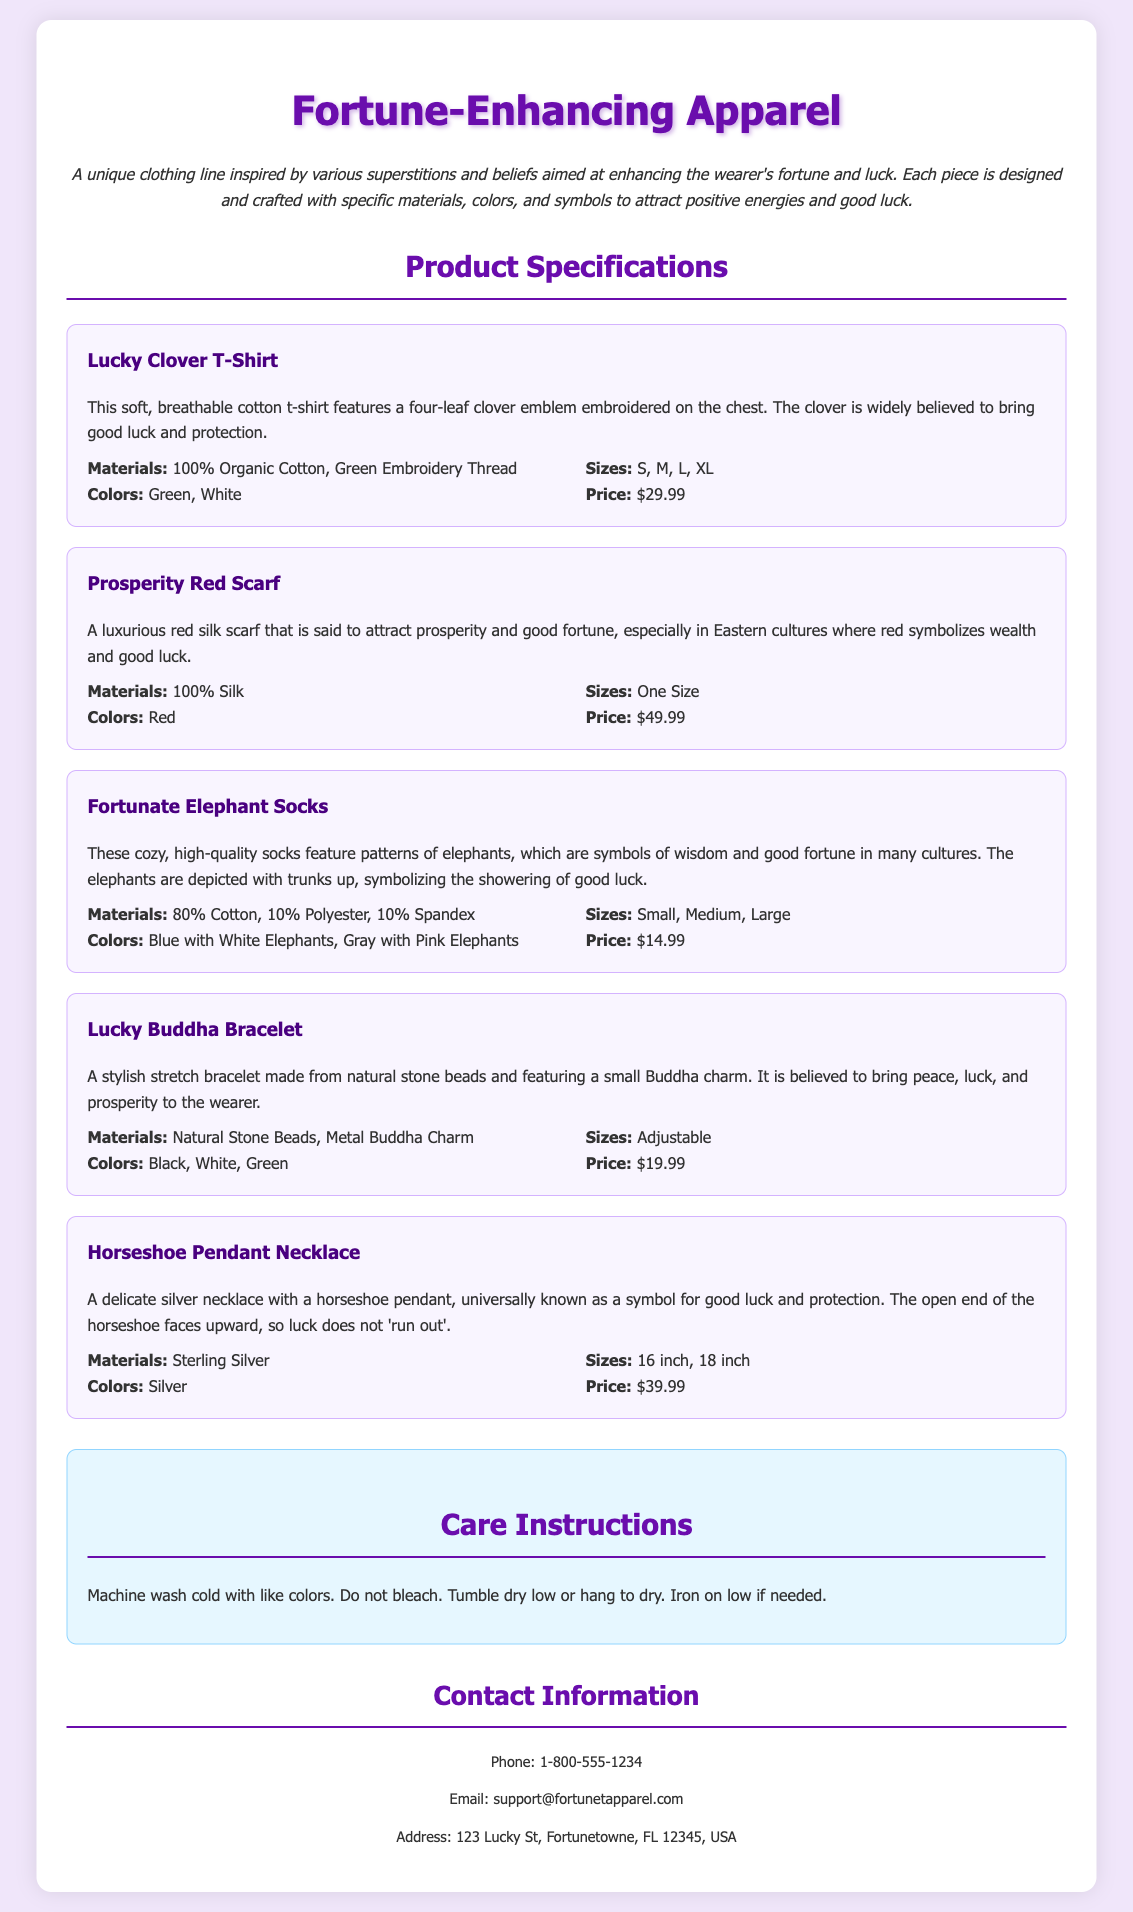What is the main theme of the clothing line? The document describes the clothing line as aimed at enhancing the wearer's fortune and luck through various superstitions and beliefs.
Answer: Fortune-Enhancing Apparel What material is the Lucky Clover T-Shirt made from? According to the specifications, the Lucky Clover T-Shirt is made of 100% Organic Cotton.
Answer: 100% Organic Cotton How much does the Prosperity Red Scarf cost? The price of the Prosperity Red Scarf is listed clearly in the specifications.
Answer: $49.99 What colors are available for the Fortunate Elephant Socks? The document provides specific details on the available colors for the socks.
Answer: Blue with White Elephants, Gray with Pink Elephants Which product features a four-leaf clover emblem? The Lucky Clover T-Shirt is specifically highlighted for having a four-leaf clover emblem embroidered on it.
Answer: Lucky Clover T-Shirt What is the adjustable size of the Lucky Buddha Bracelet? The specifications indicate the size for the Lucky Buddha Bracelet is adjustable, meaning it can fit various wrist sizes.
Answer: Adjustable What superstitious symbol is featured on the Horseshoe Pendant Necklace? The necklace prominently features a horseshoe, which is known as a symbol for good luck.
Answer: Horseshoe How should the apparel be washed according to care instructions? The care instructions specify a washing method to maintain the quality of the apparel.
Answer: Machine wash cold What is the address for customer support? The document includes contact details, including an address for customer support.
Answer: 123 Lucky St, Fortunetowne, FL 12345, USA 